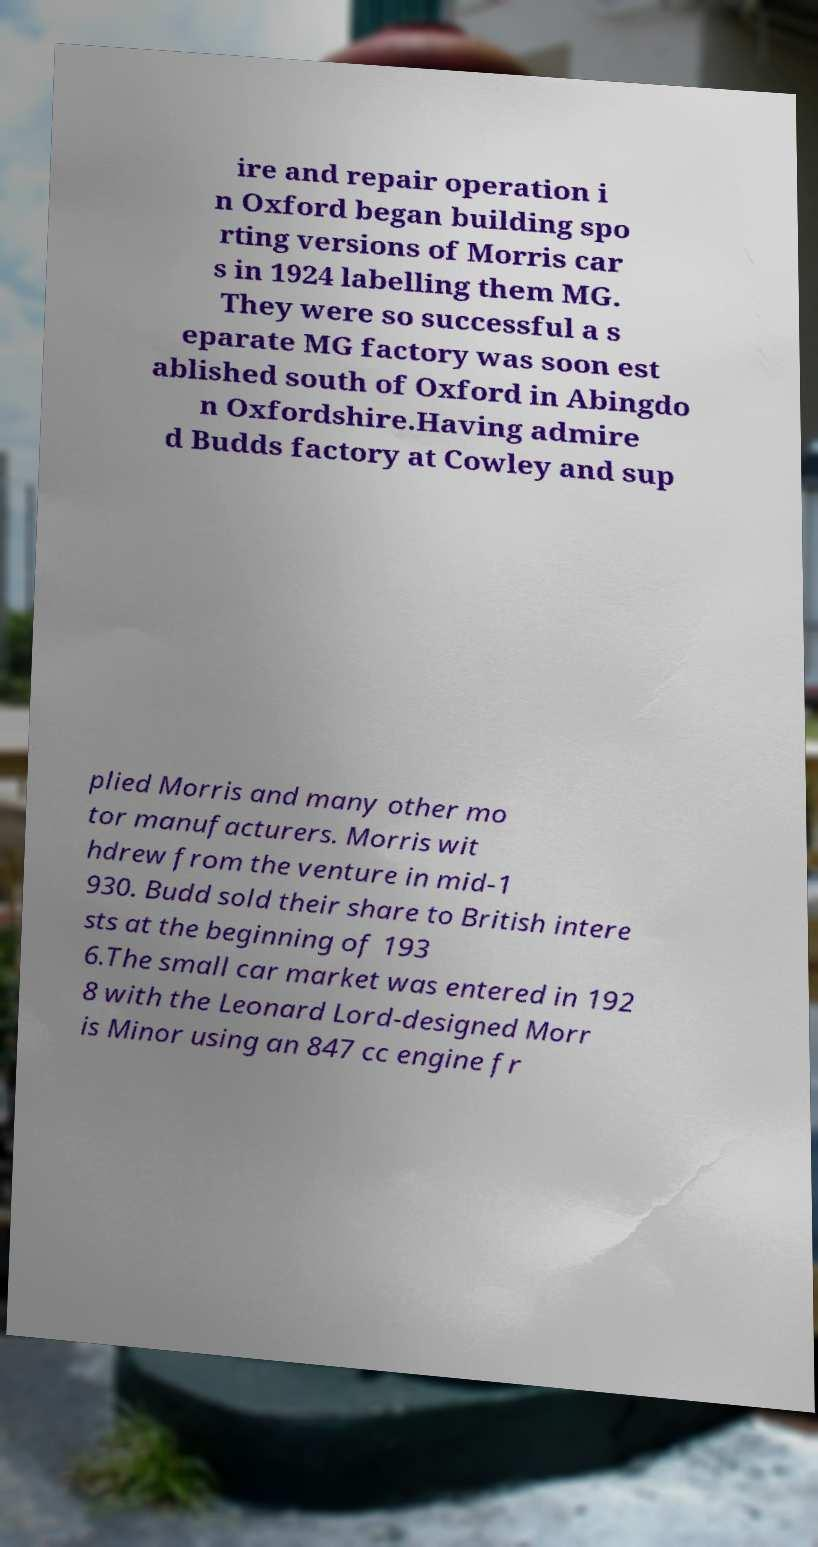What messages or text are displayed in this image? I need them in a readable, typed format. ire and repair operation i n Oxford began building spo rting versions of Morris car s in 1924 labelling them MG. They were so successful a s eparate MG factory was soon est ablished south of Oxford in Abingdo n Oxfordshire.Having admire d Budds factory at Cowley and sup plied Morris and many other mo tor manufacturers. Morris wit hdrew from the venture in mid-1 930. Budd sold their share to British intere sts at the beginning of 193 6.The small car market was entered in 192 8 with the Leonard Lord-designed Morr is Minor using an 847 cc engine fr 